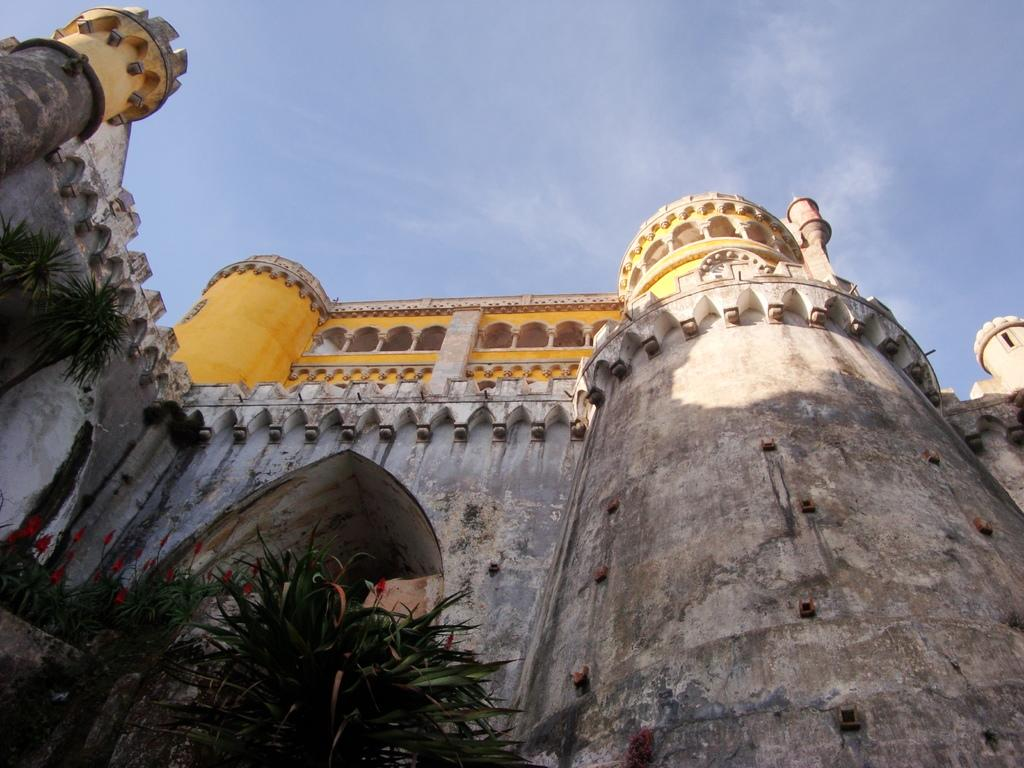What type of structure is visible in the image? There is a building in the image. What colors are used on the building? The building has yellow, brown, and cream colors. What is located in front of the building? There are plants in front of the building. What is the color of the sky in the image? The sky is blue and white in color. Can you see any bears interacting with the plants in the image? There are no bears present in the image; it features a building with plants in front. 